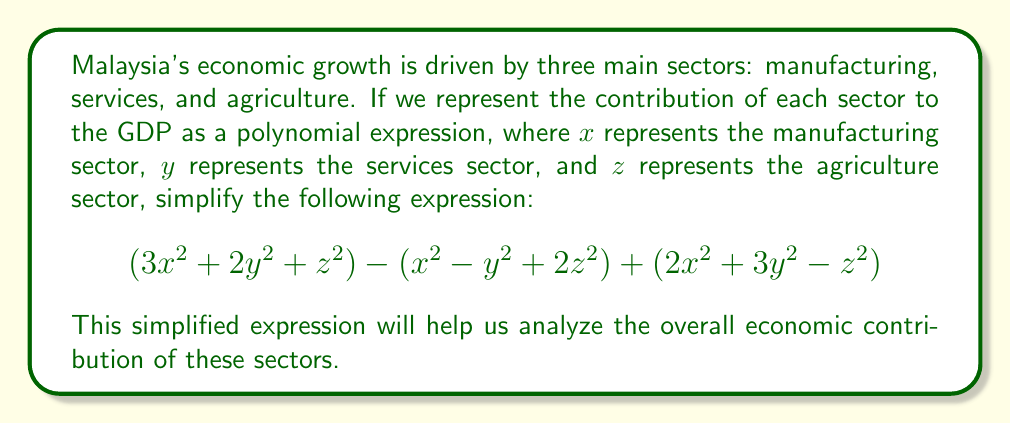Could you help me with this problem? Let's approach this step-by-step:

1) First, let's group like terms together. We have three groups of terms: $x^2$ terms, $y^2$ terms, and $z^2$ terms.

2) For $x^2$ terms:
   $3x^2 + (-x^2) + 2x^2 = 4x^2$

3) For $y^2$ terms:
   $2y^2 + y^2 + 3y^2 = 6y^2$

4) For $z^2$ terms:
   $z^2 + 2z^2 + (-z^2) = 2z^2$

5) Now, we can combine these simplified terms:

   $4x^2 + 6y^2 + 2z^2$

This is our simplified polynomial expression.
Answer: $4x^2 + 6y^2 + 2z^2$ 